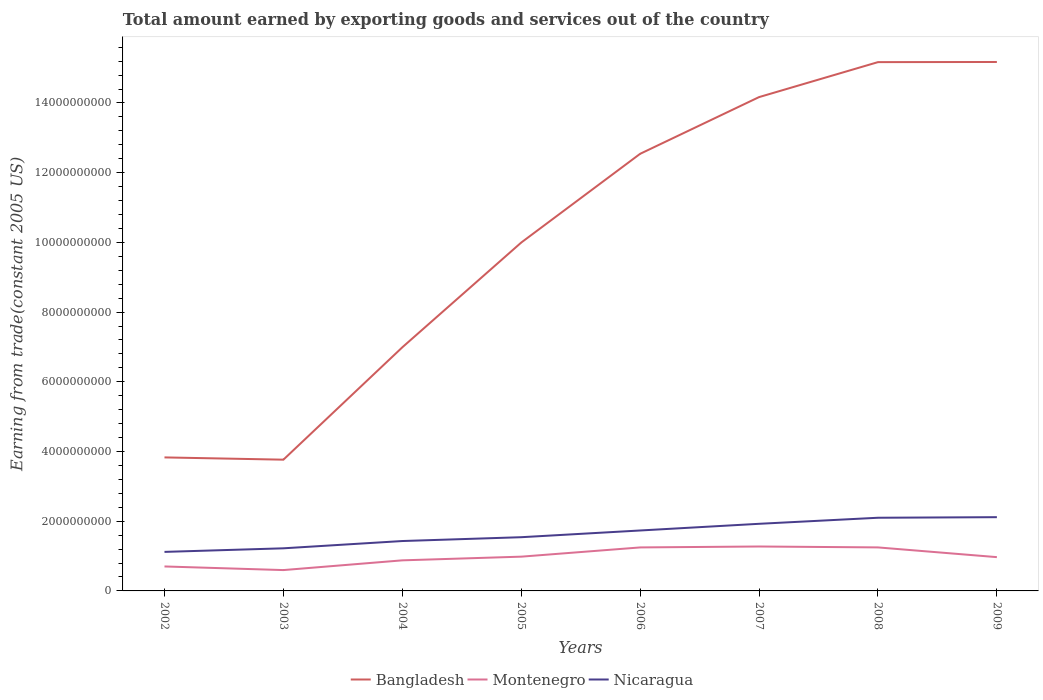How many different coloured lines are there?
Your response must be concise. 3. Does the line corresponding to Nicaragua intersect with the line corresponding to Montenegro?
Ensure brevity in your answer.  No. Is the number of lines equal to the number of legend labels?
Your answer should be very brief. Yes. Across all years, what is the maximum total amount earned by exporting goods and services in Montenegro?
Your response must be concise. 5.98e+08. In which year was the total amount earned by exporting goods and services in Bangladesh maximum?
Your response must be concise. 2003. What is the total total amount earned by exporting goods and services in Montenegro in the graph?
Offer a very short reply. -5.72e+08. What is the difference between the highest and the second highest total amount earned by exporting goods and services in Montenegro?
Provide a short and direct response. 6.76e+08. What is the difference between the highest and the lowest total amount earned by exporting goods and services in Montenegro?
Provide a short and direct response. 3. How many lines are there?
Your response must be concise. 3. How many years are there in the graph?
Your answer should be compact. 8. What is the difference between two consecutive major ticks on the Y-axis?
Your response must be concise. 2.00e+09. Are the values on the major ticks of Y-axis written in scientific E-notation?
Ensure brevity in your answer.  No. Does the graph contain any zero values?
Your response must be concise. No. Does the graph contain grids?
Your answer should be very brief. No. Where does the legend appear in the graph?
Offer a very short reply. Bottom center. How many legend labels are there?
Provide a short and direct response. 3. How are the legend labels stacked?
Provide a short and direct response. Horizontal. What is the title of the graph?
Offer a terse response. Total amount earned by exporting goods and services out of the country. Does "Pacific island small states" appear as one of the legend labels in the graph?
Give a very brief answer. No. What is the label or title of the Y-axis?
Provide a short and direct response. Earning from trade(constant 2005 US). What is the Earning from trade(constant 2005 US) of Bangladesh in 2002?
Keep it short and to the point. 3.83e+09. What is the Earning from trade(constant 2005 US) of Montenegro in 2002?
Give a very brief answer. 7.02e+08. What is the Earning from trade(constant 2005 US) in Nicaragua in 2002?
Your response must be concise. 1.12e+09. What is the Earning from trade(constant 2005 US) of Bangladesh in 2003?
Provide a succinct answer. 3.77e+09. What is the Earning from trade(constant 2005 US) in Montenegro in 2003?
Provide a short and direct response. 5.98e+08. What is the Earning from trade(constant 2005 US) of Nicaragua in 2003?
Provide a short and direct response. 1.22e+09. What is the Earning from trade(constant 2005 US) in Bangladesh in 2004?
Provide a succinct answer. 6.99e+09. What is the Earning from trade(constant 2005 US) of Montenegro in 2004?
Keep it short and to the point. 8.77e+08. What is the Earning from trade(constant 2005 US) in Nicaragua in 2004?
Your answer should be very brief. 1.43e+09. What is the Earning from trade(constant 2005 US) in Bangladesh in 2005?
Your answer should be very brief. 9.99e+09. What is the Earning from trade(constant 2005 US) in Montenegro in 2005?
Provide a succinct answer. 9.83e+08. What is the Earning from trade(constant 2005 US) of Nicaragua in 2005?
Your answer should be very brief. 1.54e+09. What is the Earning from trade(constant 2005 US) in Bangladesh in 2006?
Offer a terse response. 1.25e+1. What is the Earning from trade(constant 2005 US) of Montenegro in 2006?
Ensure brevity in your answer.  1.25e+09. What is the Earning from trade(constant 2005 US) in Nicaragua in 2006?
Offer a very short reply. 1.73e+09. What is the Earning from trade(constant 2005 US) of Bangladesh in 2007?
Offer a very short reply. 1.42e+1. What is the Earning from trade(constant 2005 US) of Montenegro in 2007?
Offer a terse response. 1.27e+09. What is the Earning from trade(constant 2005 US) in Nicaragua in 2007?
Keep it short and to the point. 1.93e+09. What is the Earning from trade(constant 2005 US) of Bangladesh in 2008?
Provide a short and direct response. 1.52e+1. What is the Earning from trade(constant 2005 US) of Montenegro in 2008?
Provide a short and direct response. 1.25e+09. What is the Earning from trade(constant 2005 US) in Nicaragua in 2008?
Your answer should be very brief. 2.10e+09. What is the Earning from trade(constant 2005 US) of Bangladesh in 2009?
Your answer should be compact. 1.52e+1. What is the Earning from trade(constant 2005 US) in Montenegro in 2009?
Ensure brevity in your answer.  9.69e+08. What is the Earning from trade(constant 2005 US) of Nicaragua in 2009?
Offer a very short reply. 2.12e+09. Across all years, what is the maximum Earning from trade(constant 2005 US) of Bangladesh?
Provide a short and direct response. 1.52e+1. Across all years, what is the maximum Earning from trade(constant 2005 US) of Montenegro?
Provide a succinct answer. 1.27e+09. Across all years, what is the maximum Earning from trade(constant 2005 US) in Nicaragua?
Make the answer very short. 2.12e+09. Across all years, what is the minimum Earning from trade(constant 2005 US) in Bangladesh?
Your answer should be compact. 3.77e+09. Across all years, what is the minimum Earning from trade(constant 2005 US) in Montenegro?
Provide a succinct answer. 5.98e+08. Across all years, what is the minimum Earning from trade(constant 2005 US) in Nicaragua?
Your answer should be compact. 1.12e+09. What is the total Earning from trade(constant 2005 US) in Bangladesh in the graph?
Give a very brief answer. 8.16e+1. What is the total Earning from trade(constant 2005 US) in Montenegro in the graph?
Offer a very short reply. 7.90e+09. What is the total Earning from trade(constant 2005 US) of Nicaragua in the graph?
Offer a terse response. 1.32e+1. What is the difference between the Earning from trade(constant 2005 US) of Bangladesh in 2002 and that in 2003?
Give a very brief answer. 6.50e+07. What is the difference between the Earning from trade(constant 2005 US) in Montenegro in 2002 and that in 2003?
Make the answer very short. 1.04e+08. What is the difference between the Earning from trade(constant 2005 US) in Nicaragua in 2002 and that in 2003?
Your response must be concise. -1.03e+08. What is the difference between the Earning from trade(constant 2005 US) of Bangladesh in 2002 and that in 2004?
Your response must be concise. -3.16e+09. What is the difference between the Earning from trade(constant 2005 US) of Montenegro in 2002 and that in 2004?
Your answer should be very brief. -1.75e+08. What is the difference between the Earning from trade(constant 2005 US) of Nicaragua in 2002 and that in 2004?
Your answer should be compact. -3.12e+08. What is the difference between the Earning from trade(constant 2005 US) of Bangladesh in 2002 and that in 2005?
Provide a succinct answer. -6.16e+09. What is the difference between the Earning from trade(constant 2005 US) in Montenegro in 2002 and that in 2005?
Give a very brief answer. -2.81e+08. What is the difference between the Earning from trade(constant 2005 US) in Nicaragua in 2002 and that in 2005?
Make the answer very short. -4.22e+08. What is the difference between the Earning from trade(constant 2005 US) of Bangladesh in 2002 and that in 2006?
Provide a short and direct response. -8.71e+09. What is the difference between the Earning from trade(constant 2005 US) in Montenegro in 2002 and that in 2006?
Keep it short and to the point. -5.46e+08. What is the difference between the Earning from trade(constant 2005 US) of Nicaragua in 2002 and that in 2006?
Make the answer very short. -6.14e+08. What is the difference between the Earning from trade(constant 2005 US) of Bangladesh in 2002 and that in 2007?
Your answer should be very brief. -1.03e+1. What is the difference between the Earning from trade(constant 2005 US) of Montenegro in 2002 and that in 2007?
Make the answer very short. -5.72e+08. What is the difference between the Earning from trade(constant 2005 US) of Nicaragua in 2002 and that in 2007?
Provide a succinct answer. -8.06e+08. What is the difference between the Earning from trade(constant 2005 US) in Bangladesh in 2002 and that in 2008?
Your answer should be very brief. -1.13e+1. What is the difference between the Earning from trade(constant 2005 US) in Montenegro in 2002 and that in 2008?
Make the answer very short. -5.46e+08. What is the difference between the Earning from trade(constant 2005 US) in Nicaragua in 2002 and that in 2008?
Provide a succinct answer. -9.80e+08. What is the difference between the Earning from trade(constant 2005 US) in Bangladesh in 2002 and that in 2009?
Provide a short and direct response. -1.13e+1. What is the difference between the Earning from trade(constant 2005 US) of Montenegro in 2002 and that in 2009?
Give a very brief answer. -2.67e+08. What is the difference between the Earning from trade(constant 2005 US) in Nicaragua in 2002 and that in 2009?
Offer a terse response. -9.96e+08. What is the difference between the Earning from trade(constant 2005 US) of Bangladesh in 2003 and that in 2004?
Ensure brevity in your answer.  -3.22e+09. What is the difference between the Earning from trade(constant 2005 US) of Montenegro in 2003 and that in 2004?
Keep it short and to the point. -2.79e+08. What is the difference between the Earning from trade(constant 2005 US) of Nicaragua in 2003 and that in 2004?
Your response must be concise. -2.09e+08. What is the difference between the Earning from trade(constant 2005 US) in Bangladesh in 2003 and that in 2005?
Your response must be concise. -6.23e+09. What is the difference between the Earning from trade(constant 2005 US) of Montenegro in 2003 and that in 2005?
Give a very brief answer. -3.85e+08. What is the difference between the Earning from trade(constant 2005 US) of Nicaragua in 2003 and that in 2005?
Provide a short and direct response. -3.19e+08. What is the difference between the Earning from trade(constant 2005 US) in Bangladesh in 2003 and that in 2006?
Keep it short and to the point. -8.78e+09. What is the difference between the Earning from trade(constant 2005 US) of Montenegro in 2003 and that in 2006?
Your response must be concise. -6.50e+08. What is the difference between the Earning from trade(constant 2005 US) in Nicaragua in 2003 and that in 2006?
Ensure brevity in your answer.  -5.11e+08. What is the difference between the Earning from trade(constant 2005 US) of Bangladesh in 2003 and that in 2007?
Offer a terse response. -1.04e+1. What is the difference between the Earning from trade(constant 2005 US) in Montenegro in 2003 and that in 2007?
Provide a succinct answer. -6.76e+08. What is the difference between the Earning from trade(constant 2005 US) of Nicaragua in 2003 and that in 2007?
Your answer should be very brief. -7.03e+08. What is the difference between the Earning from trade(constant 2005 US) in Bangladesh in 2003 and that in 2008?
Your answer should be compact. -1.14e+1. What is the difference between the Earning from trade(constant 2005 US) of Montenegro in 2003 and that in 2008?
Your response must be concise. -6.50e+08. What is the difference between the Earning from trade(constant 2005 US) in Nicaragua in 2003 and that in 2008?
Provide a succinct answer. -8.77e+08. What is the difference between the Earning from trade(constant 2005 US) in Bangladesh in 2003 and that in 2009?
Offer a very short reply. -1.14e+1. What is the difference between the Earning from trade(constant 2005 US) of Montenegro in 2003 and that in 2009?
Provide a succinct answer. -3.71e+08. What is the difference between the Earning from trade(constant 2005 US) of Nicaragua in 2003 and that in 2009?
Keep it short and to the point. -8.94e+08. What is the difference between the Earning from trade(constant 2005 US) of Bangladesh in 2004 and that in 2005?
Give a very brief answer. -3.01e+09. What is the difference between the Earning from trade(constant 2005 US) of Montenegro in 2004 and that in 2005?
Provide a short and direct response. -1.06e+08. What is the difference between the Earning from trade(constant 2005 US) in Nicaragua in 2004 and that in 2005?
Keep it short and to the point. -1.10e+08. What is the difference between the Earning from trade(constant 2005 US) of Bangladesh in 2004 and that in 2006?
Your response must be concise. -5.55e+09. What is the difference between the Earning from trade(constant 2005 US) in Montenegro in 2004 and that in 2006?
Your response must be concise. -3.70e+08. What is the difference between the Earning from trade(constant 2005 US) in Nicaragua in 2004 and that in 2006?
Your response must be concise. -3.02e+08. What is the difference between the Earning from trade(constant 2005 US) in Bangladesh in 2004 and that in 2007?
Offer a very short reply. -7.18e+09. What is the difference between the Earning from trade(constant 2005 US) of Montenegro in 2004 and that in 2007?
Your answer should be compact. -3.97e+08. What is the difference between the Earning from trade(constant 2005 US) in Nicaragua in 2004 and that in 2007?
Your answer should be compact. -4.94e+08. What is the difference between the Earning from trade(constant 2005 US) in Bangladesh in 2004 and that in 2008?
Offer a terse response. -8.18e+09. What is the difference between the Earning from trade(constant 2005 US) in Montenegro in 2004 and that in 2008?
Ensure brevity in your answer.  -3.71e+08. What is the difference between the Earning from trade(constant 2005 US) of Nicaragua in 2004 and that in 2008?
Provide a succinct answer. -6.68e+08. What is the difference between the Earning from trade(constant 2005 US) of Bangladesh in 2004 and that in 2009?
Your answer should be very brief. -8.19e+09. What is the difference between the Earning from trade(constant 2005 US) in Montenegro in 2004 and that in 2009?
Your response must be concise. -9.19e+07. What is the difference between the Earning from trade(constant 2005 US) of Nicaragua in 2004 and that in 2009?
Your answer should be compact. -6.85e+08. What is the difference between the Earning from trade(constant 2005 US) of Bangladesh in 2005 and that in 2006?
Make the answer very short. -2.55e+09. What is the difference between the Earning from trade(constant 2005 US) of Montenegro in 2005 and that in 2006?
Offer a terse response. -2.65e+08. What is the difference between the Earning from trade(constant 2005 US) in Nicaragua in 2005 and that in 2006?
Give a very brief answer. -1.93e+08. What is the difference between the Earning from trade(constant 2005 US) in Bangladesh in 2005 and that in 2007?
Offer a terse response. -4.17e+09. What is the difference between the Earning from trade(constant 2005 US) in Montenegro in 2005 and that in 2007?
Provide a short and direct response. -2.91e+08. What is the difference between the Earning from trade(constant 2005 US) in Nicaragua in 2005 and that in 2007?
Provide a short and direct response. -3.84e+08. What is the difference between the Earning from trade(constant 2005 US) of Bangladesh in 2005 and that in 2008?
Make the answer very short. -5.18e+09. What is the difference between the Earning from trade(constant 2005 US) in Montenegro in 2005 and that in 2008?
Offer a terse response. -2.65e+08. What is the difference between the Earning from trade(constant 2005 US) in Nicaragua in 2005 and that in 2008?
Your response must be concise. -5.58e+08. What is the difference between the Earning from trade(constant 2005 US) of Bangladesh in 2005 and that in 2009?
Offer a terse response. -5.18e+09. What is the difference between the Earning from trade(constant 2005 US) of Montenegro in 2005 and that in 2009?
Offer a terse response. 1.37e+07. What is the difference between the Earning from trade(constant 2005 US) in Nicaragua in 2005 and that in 2009?
Offer a terse response. -5.75e+08. What is the difference between the Earning from trade(constant 2005 US) of Bangladesh in 2006 and that in 2007?
Give a very brief answer. -1.63e+09. What is the difference between the Earning from trade(constant 2005 US) of Montenegro in 2006 and that in 2007?
Your response must be concise. -2.65e+07. What is the difference between the Earning from trade(constant 2005 US) in Nicaragua in 2006 and that in 2007?
Your answer should be compact. -1.92e+08. What is the difference between the Earning from trade(constant 2005 US) of Bangladesh in 2006 and that in 2008?
Ensure brevity in your answer.  -2.63e+09. What is the difference between the Earning from trade(constant 2005 US) in Montenegro in 2006 and that in 2008?
Keep it short and to the point. -4.10e+05. What is the difference between the Earning from trade(constant 2005 US) in Nicaragua in 2006 and that in 2008?
Provide a succinct answer. -3.66e+08. What is the difference between the Earning from trade(constant 2005 US) in Bangladesh in 2006 and that in 2009?
Provide a succinct answer. -2.63e+09. What is the difference between the Earning from trade(constant 2005 US) of Montenegro in 2006 and that in 2009?
Your response must be concise. 2.79e+08. What is the difference between the Earning from trade(constant 2005 US) in Nicaragua in 2006 and that in 2009?
Offer a terse response. -3.82e+08. What is the difference between the Earning from trade(constant 2005 US) of Bangladesh in 2007 and that in 2008?
Offer a very short reply. -1.00e+09. What is the difference between the Earning from trade(constant 2005 US) in Montenegro in 2007 and that in 2008?
Offer a very short reply. 2.61e+07. What is the difference between the Earning from trade(constant 2005 US) in Nicaragua in 2007 and that in 2008?
Your response must be concise. -1.74e+08. What is the difference between the Earning from trade(constant 2005 US) of Bangladesh in 2007 and that in 2009?
Your response must be concise. -1.01e+09. What is the difference between the Earning from trade(constant 2005 US) of Montenegro in 2007 and that in 2009?
Provide a short and direct response. 3.05e+08. What is the difference between the Earning from trade(constant 2005 US) of Nicaragua in 2007 and that in 2009?
Provide a short and direct response. -1.90e+08. What is the difference between the Earning from trade(constant 2005 US) in Bangladesh in 2008 and that in 2009?
Keep it short and to the point. -4.32e+06. What is the difference between the Earning from trade(constant 2005 US) of Montenegro in 2008 and that in 2009?
Your answer should be very brief. 2.79e+08. What is the difference between the Earning from trade(constant 2005 US) of Nicaragua in 2008 and that in 2009?
Your answer should be compact. -1.68e+07. What is the difference between the Earning from trade(constant 2005 US) of Bangladesh in 2002 and the Earning from trade(constant 2005 US) of Montenegro in 2003?
Make the answer very short. 3.23e+09. What is the difference between the Earning from trade(constant 2005 US) of Bangladesh in 2002 and the Earning from trade(constant 2005 US) of Nicaragua in 2003?
Offer a very short reply. 2.61e+09. What is the difference between the Earning from trade(constant 2005 US) in Montenegro in 2002 and the Earning from trade(constant 2005 US) in Nicaragua in 2003?
Offer a very short reply. -5.20e+08. What is the difference between the Earning from trade(constant 2005 US) of Bangladesh in 2002 and the Earning from trade(constant 2005 US) of Montenegro in 2004?
Offer a terse response. 2.95e+09. What is the difference between the Earning from trade(constant 2005 US) of Bangladesh in 2002 and the Earning from trade(constant 2005 US) of Nicaragua in 2004?
Ensure brevity in your answer.  2.40e+09. What is the difference between the Earning from trade(constant 2005 US) in Montenegro in 2002 and the Earning from trade(constant 2005 US) in Nicaragua in 2004?
Offer a terse response. -7.29e+08. What is the difference between the Earning from trade(constant 2005 US) of Bangladesh in 2002 and the Earning from trade(constant 2005 US) of Montenegro in 2005?
Provide a short and direct response. 2.85e+09. What is the difference between the Earning from trade(constant 2005 US) in Bangladesh in 2002 and the Earning from trade(constant 2005 US) in Nicaragua in 2005?
Ensure brevity in your answer.  2.29e+09. What is the difference between the Earning from trade(constant 2005 US) of Montenegro in 2002 and the Earning from trade(constant 2005 US) of Nicaragua in 2005?
Keep it short and to the point. -8.39e+08. What is the difference between the Earning from trade(constant 2005 US) of Bangladesh in 2002 and the Earning from trade(constant 2005 US) of Montenegro in 2006?
Offer a terse response. 2.58e+09. What is the difference between the Earning from trade(constant 2005 US) of Bangladesh in 2002 and the Earning from trade(constant 2005 US) of Nicaragua in 2006?
Offer a very short reply. 2.10e+09. What is the difference between the Earning from trade(constant 2005 US) of Montenegro in 2002 and the Earning from trade(constant 2005 US) of Nicaragua in 2006?
Give a very brief answer. -1.03e+09. What is the difference between the Earning from trade(constant 2005 US) of Bangladesh in 2002 and the Earning from trade(constant 2005 US) of Montenegro in 2007?
Provide a short and direct response. 2.56e+09. What is the difference between the Earning from trade(constant 2005 US) in Bangladesh in 2002 and the Earning from trade(constant 2005 US) in Nicaragua in 2007?
Your answer should be compact. 1.90e+09. What is the difference between the Earning from trade(constant 2005 US) in Montenegro in 2002 and the Earning from trade(constant 2005 US) in Nicaragua in 2007?
Your response must be concise. -1.22e+09. What is the difference between the Earning from trade(constant 2005 US) in Bangladesh in 2002 and the Earning from trade(constant 2005 US) in Montenegro in 2008?
Provide a succinct answer. 2.58e+09. What is the difference between the Earning from trade(constant 2005 US) in Bangladesh in 2002 and the Earning from trade(constant 2005 US) in Nicaragua in 2008?
Your answer should be very brief. 1.73e+09. What is the difference between the Earning from trade(constant 2005 US) in Montenegro in 2002 and the Earning from trade(constant 2005 US) in Nicaragua in 2008?
Your response must be concise. -1.40e+09. What is the difference between the Earning from trade(constant 2005 US) of Bangladesh in 2002 and the Earning from trade(constant 2005 US) of Montenegro in 2009?
Offer a terse response. 2.86e+09. What is the difference between the Earning from trade(constant 2005 US) in Bangladesh in 2002 and the Earning from trade(constant 2005 US) in Nicaragua in 2009?
Offer a terse response. 1.71e+09. What is the difference between the Earning from trade(constant 2005 US) of Montenegro in 2002 and the Earning from trade(constant 2005 US) of Nicaragua in 2009?
Keep it short and to the point. -1.41e+09. What is the difference between the Earning from trade(constant 2005 US) in Bangladesh in 2003 and the Earning from trade(constant 2005 US) in Montenegro in 2004?
Your answer should be very brief. 2.89e+09. What is the difference between the Earning from trade(constant 2005 US) in Bangladesh in 2003 and the Earning from trade(constant 2005 US) in Nicaragua in 2004?
Keep it short and to the point. 2.33e+09. What is the difference between the Earning from trade(constant 2005 US) of Montenegro in 2003 and the Earning from trade(constant 2005 US) of Nicaragua in 2004?
Your answer should be very brief. -8.34e+08. What is the difference between the Earning from trade(constant 2005 US) of Bangladesh in 2003 and the Earning from trade(constant 2005 US) of Montenegro in 2005?
Give a very brief answer. 2.78e+09. What is the difference between the Earning from trade(constant 2005 US) of Bangladesh in 2003 and the Earning from trade(constant 2005 US) of Nicaragua in 2005?
Your answer should be very brief. 2.22e+09. What is the difference between the Earning from trade(constant 2005 US) in Montenegro in 2003 and the Earning from trade(constant 2005 US) in Nicaragua in 2005?
Keep it short and to the point. -9.43e+08. What is the difference between the Earning from trade(constant 2005 US) in Bangladesh in 2003 and the Earning from trade(constant 2005 US) in Montenegro in 2006?
Offer a very short reply. 2.52e+09. What is the difference between the Earning from trade(constant 2005 US) of Bangladesh in 2003 and the Earning from trade(constant 2005 US) of Nicaragua in 2006?
Keep it short and to the point. 2.03e+09. What is the difference between the Earning from trade(constant 2005 US) of Montenegro in 2003 and the Earning from trade(constant 2005 US) of Nicaragua in 2006?
Make the answer very short. -1.14e+09. What is the difference between the Earning from trade(constant 2005 US) of Bangladesh in 2003 and the Earning from trade(constant 2005 US) of Montenegro in 2007?
Make the answer very short. 2.49e+09. What is the difference between the Earning from trade(constant 2005 US) of Bangladesh in 2003 and the Earning from trade(constant 2005 US) of Nicaragua in 2007?
Give a very brief answer. 1.84e+09. What is the difference between the Earning from trade(constant 2005 US) of Montenegro in 2003 and the Earning from trade(constant 2005 US) of Nicaragua in 2007?
Offer a very short reply. -1.33e+09. What is the difference between the Earning from trade(constant 2005 US) in Bangladesh in 2003 and the Earning from trade(constant 2005 US) in Montenegro in 2008?
Your answer should be very brief. 2.52e+09. What is the difference between the Earning from trade(constant 2005 US) in Bangladesh in 2003 and the Earning from trade(constant 2005 US) in Nicaragua in 2008?
Keep it short and to the point. 1.67e+09. What is the difference between the Earning from trade(constant 2005 US) of Montenegro in 2003 and the Earning from trade(constant 2005 US) of Nicaragua in 2008?
Provide a short and direct response. -1.50e+09. What is the difference between the Earning from trade(constant 2005 US) in Bangladesh in 2003 and the Earning from trade(constant 2005 US) in Montenegro in 2009?
Keep it short and to the point. 2.80e+09. What is the difference between the Earning from trade(constant 2005 US) of Bangladesh in 2003 and the Earning from trade(constant 2005 US) of Nicaragua in 2009?
Ensure brevity in your answer.  1.65e+09. What is the difference between the Earning from trade(constant 2005 US) of Montenegro in 2003 and the Earning from trade(constant 2005 US) of Nicaragua in 2009?
Give a very brief answer. -1.52e+09. What is the difference between the Earning from trade(constant 2005 US) in Bangladesh in 2004 and the Earning from trade(constant 2005 US) in Montenegro in 2005?
Your answer should be compact. 6.01e+09. What is the difference between the Earning from trade(constant 2005 US) in Bangladesh in 2004 and the Earning from trade(constant 2005 US) in Nicaragua in 2005?
Ensure brevity in your answer.  5.45e+09. What is the difference between the Earning from trade(constant 2005 US) of Montenegro in 2004 and the Earning from trade(constant 2005 US) of Nicaragua in 2005?
Ensure brevity in your answer.  -6.64e+08. What is the difference between the Earning from trade(constant 2005 US) of Bangladesh in 2004 and the Earning from trade(constant 2005 US) of Montenegro in 2006?
Provide a succinct answer. 5.74e+09. What is the difference between the Earning from trade(constant 2005 US) in Bangladesh in 2004 and the Earning from trade(constant 2005 US) in Nicaragua in 2006?
Ensure brevity in your answer.  5.26e+09. What is the difference between the Earning from trade(constant 2005 US) in Montenegro in 2004 and the Earning from trade(constant 2005 US) in Nicaragua in 2006?
Your answer should be very brief. -8.56e+08. What is the difference between the Earning from trade(constant 2005 US) of Bangladesh in 2004 and the Earning from trade(constant 2005 US) of Montenegro in 2007?
Your response must be concise. 5.71e+09. What is the difference between the Earning from trade(constant 2005 US) of Bangladesh in 2004 and the Earning from trade(constant 2005 US) of Nicaragua in 2007?
Make the answer very short. 5.06e+09. What is the difference between the Earning from trade(constant 2005 US) of Montenegro in 2004 and the Earning from trade(constant 2005 US) of Nicaragua in 2007?
Offer a very short reply. -1.05e+09. What is the difference between the Earning from trade(constant 2005 US) of Bangladesh in 2004 and the Earning from trade(constant 2005 US) of Montenegro in 2008?
Give a very brief answer. 5.74e+09. What is the difference between the Earning from trade(constant 2005 US) in Bangladesh in 2004 and the Earning from trade(constant 2005 US) in Nicaragua in 2008?
Your answer should be very brief. 4.89e+09. What is the difference between the Earning from trade(constant 2005 US) in Montenegro in 2004 and the Earning from trade(constant 2005 US) in Nicaragua in 2008?
Your answer should be compact. -1.22e+09. What is the difference between the Earning from trade(constant 2005 US) in Bangladesh in 2004 and the Earning from trade(constant 2005 US) in Montenegro in 2009?
Provide a succinct answer. 6.02e+09. What is the difference between the Earning from trade(constant 2005 US) in Bangladesh in 2004 and the Earning from trade(constant 2005 US) in Nicaragua in 2009?
Your answer should be very brief. 4.87e+09. What is the difference between the Earning from trade(constant 2005 US) of Montenegro in 2004 and the Earning from trade(constant 2005 US) of Nicaragua in 2009?
Provide a succinct answer. -1.24e+09. What is the difference between the Earning from trade(constant 2005 US) of Bangladesh in 2005 and the Earning from trade(constant 2005 US) of Montenegro in 2006?
Provide a short and direct response. 8.75e+09. What is the difference between the Earning from trade(constant 2005 US) in Bangladesh in 2005 and the Earning from trade(constant 2005 US) in Nicaragua in 2006?
Provide a short and direct response. 8.26e+09. What is the difference between the Earning from trade(constant 2005 US) of Montenegro in 2005 and the Earning from trade(constant 2005 US) of Nicaragua in 2006?
Make the answer very short. -7.51e+08. What is the difference between the Earning from trade(constant 2005 US) of Bangladesh in 2005 and the Earning from trade(constant 2005 US) of Montenegro in 2007?
Your answer should be very brief. 8.72e+09. What is the difference between the Earning from trade(constant 2005 US) in Bangladesh in 2005 and the Earning from trade(constant 2005 US) in Nicaragua in 2007?
Your answer should be compact. 8.07e+09. What is the difference between the Earning from trade(constant 2005 US) in Montenegro in 2005 and the Earning from trade(constant 2005 US) in Nicaragua in 2007?
Ensure brevity in your answer.  -9.43e+08. What is the difference between the Earning from trade(constant 2005 US) in Bangladesh in 2005 and the Earning from trade(constant 2005 US) in Montenegro in 2008?
Offer a terse response. 8.75e+09. What is the difference between the Earning from trade(constant 2005 US) in Bangladesh in 2005 and the Earning from trade(constant 2005 US) in Nicaragua in 2008?
Keep it short and to the point. 7.90e+09. What is the difference between the Earning from trade(constant 2005 US) of Montenegro in 2005 and the Earning from trade(constant 2005 US) of Nicaragua in 2008?
Your response must be concise. -1.12e+09. What is the difference between the Earning from trade(constant 2005 US) in Bangladesh in 2005 and the Earning from trade(constant 2005 US) in Montenegro in 2009?
Your response must be concise. 9.03e+09. What is the difference between the Earning from trade(constant 2005 US) of Bangladesh in 2005 and the Earning from trade(constant 2005 US) of Nicaragua in 2009?
Offer a very short reply. 7.88e+09. What is the difference between the Earning from trade(constant 2005 US) of Montenegro in 2005 and the Earning from trade(constant 2005 US) of Nicaragua in 2009?
Ensure brevity in your answer.  -1.13e+09. What is the difference between the Earning from trade(constant 2005 US) in Bangladesh in 2006 and the Earning from trade(constant 2005 US) in Montenegro in 2007?
Offer a very short reply. 1.13e+1. What is the difference between the Earning from trade(constant 2005 US) in Bangladesh in 2006 and the Earning from trade(constant 2005 US) in Nicaragua in 2007?
Offer a terse response. 1.06e+1. What is the difference between the Earning from trade(constant 2005 US) of Montenegro in 2006 and the Earning from trade(constant 2005 US) of Nicaragua in 2007?
Your answer should be very brief. -6.78e+08. What is the difference between the Earning from trade(constant 2005 US) of Bangladesh in 2006 and the Earning from trade(constant 2005 US) of Montenegro in 2008?
Provide a succinct answer. 1.13e+1. What is the difference between the Earning from trade(constant 2005 US) in Bangladesh in 2006 and the Earning from trade(constant 2005 US) in Nicaragua in 2008?
Keep it short and to the point. 1.04e+1. What is the difference between the Earning from trade(constant 2005 US) in Montenegro in 2006 and the Earning from trade(constant 2005 US) in Nicaragua in 2008?
Provide a succinct answer. -8.51e+08. What is the difference between the Earning from trade(constant 2005 US) of Bangladesh in 2006 and the Earning from trade(constant 2005 US) of Montenegro in 2009?
Offer a terse response. 1.16e+1. What is the difference between the Earning from trade(constant 2005 US) of Bangladesh in 2006 and the Earning from trade(constant 2005 US) of Nicaragua in 2009?
Keep it short and to the point. 1.04e+1. What is the difference between the Earning from trade(constant 2005 US) in Montenegro in 2006 and the Earning from trade(constant 2005 US) in Nicaragua in 2009?
Give a very brief answer. -8.68e+08. What is the difference between the Earning from trade(constant 2005 US) in Bangladesh in 2007 and the Earning from trade(constant 2005 US) in Montenegro in 2008?
Offer a very short reply. 1.29e+1. What is the difference between the Earning from trade(constant 2005 US) in Bangladesh in 2007 and the Earning from trade(constant 2005 US) in Nicaragua in 2008?
Provide a succinct answer. 1.21e+1. What is the difference between the Earning from trade(constant 2005 US) of Montenegro in 2007 and the Earning from trade(constant 2005 US) of Nicaragua in 2008?
Your answer should be compact. -8.25e+08. What is the difference between the Earning from trade(constant 2005 US) in Bangladesh in 2007 and the Earning from trade(constant 2005 US) in Montenegro in 2009?
Your answer should be compact. 1.32e+1. What is the difference between the Earning from trade(constant 2005 US) in Bangladesh in 2007 and the Earning from trade(constant 2005 US) in Nicaragua in 2009?
Your answer should be very brief. 1.21e+1. What is the difference between the Earning from trade(constant 2005 US) of Montenegro in 2007 and the Earning from trade(constant 2005 US) of Nicaragua in 2009?
Keep it short and to the point. -8.42e+08. What is the difference between the Earning from trade(constant 2005 US) in Bangladesh in 2008 and the Earning from trade(constant 2005 US) in Montenegro in 2009?
Provide a succinct answer. 1.42e+1. What is the difference between the Earning from trade(constant 2005 US) of Bangladesh in 2008 and the Earning from trade(constant 2005 US) of Nicaragua in 2009?
Offer a very short reply. 1.31e+1. What is the difference between the Earning from trade(constant 2005 US) in Montenegro in 2008 and the Earning from trade(constant 2005 US) in Nicaragua in 2009?
Your response must be concise. -8.68e+08. What is the average Earning from trade(constant 2005 US) of Bangladesh per year?
Your answer should be compact. 1.02e+1. What is the average Earning from trade(constant 2005 US) in Montenegro per year?
Your answer should be very brief. 9.88e+08. What is the average Earning from trade(constant 2005 US) of Nicaragua per year?
Offer a terse response. 1.65e+09. In the year 2002, what is the difference between the Earning from trade(constant 2005 US) of Bangladesh and Earning from trade(constant 2005 US) of Montenegro?
Provide a short and direct response. 3.13e+09. In the year 2002, what is the difference between the Earning from trade(constant 2005 US) in Bangladesh and Earning from trade(constant 2005 US) in Nicaragua?
Keep it short and to the point. 2.71e+09. In the year 2002, what is the difference between the Earning from trade(constant 2005 US) in Montenegro and Earning from trade(constant 2005 US) in Nicaragua?
Provide a succinct answer. -4.18e+08. In the year 2003, what is the difference between the Earning from trade(constant 2005 US) of Bangladesh and Earning from trade(constant 2005 US) of Montenegro?
Keep it short and to the point. 3.17e+09. In the year 2003, what is the difference between the Earning from trade(constant 2005 US) in Bangladesh and Earning from trade(constant 2005 US) in Nicaragua?
Ensure brevity in your answer.  2.54e+09. In the year 2003, what is the difference between the Earning from trade(constant 2005 US) in Montenegro and Earning from trade(constant 2005 US) in Nicaragua?
Your answer should be compact. -6.24e+08. In the year 2004, what is the difference between the Earning from trade(constant 2005 US) of Bangladesh and Earning from trade(constant 2005 US) of Montenegro?
Offer a terse response. 6.11e+09. In the year 2004, what is the difference between the Earning from trade(constant 2005 US) of Bangladesh and Earning from trade(constant 2005 US) of Nicaragua?
Keep it short and to the point. 5.56e+09. In the year 2004, what is the difference between the Earning from trade(constant 2005 US) in Montenegro and Earning from trade(constant 2005 US) in Nicaragua?
Your response must be concise. -5.54e+08. In the year 2005, what is the difference between the Earning from trade(constant 2005 US) of Bangladesh and Earning from trade(constant 2005 US) of Montenegro?
Your answer should be compact. 9.01e+09. In the year 2005, what is the difference between the Earning from trade(constant 2005 US) in Bangladesh and Earning from trade(constant 2005 US) in Nicaragua?
Your response must be concise. 8.45e+09. In the year 2005, what is the difference between the Earning from trade(constant 2005 US) of Montenegro and Earning from trade(constant 2005 US) of Nicaragua?
Provide a succinct answer. -5.58e+08. In the year 2006, what is the difference between the Earning from trade(constant 2005 US) in Bangladesh and Earning from trade(constant 2005 US) in Montenegro?
Offer a very short reply. 1.13e+1. In the year 2006, what is the difference between the Earning from trade(constant 2005 US) in Bangladesh and Earning from trade(constant 2005 US) in Nicaragua?
Ensure brevity in your answer.  1.08e+1. In the year 2006, what is the difference between the Earning from trade(constant 2005 US) of Montenegro and Earning from trade(constant 2005 US) of Nicaragua?
Keep it short and to the point. -4.86e+08. In the year 2007, what is the difference between the Earning from trade(constant 2005 US) of Bangladesh and Earning from trade(constant 2005 US) of Montenegro?
Provide a short and direct response. 1.29e+1. In the year 2007, what is the difference between the Earning from trade(constant 2005 US) in Bangladesh and Earning from trade(constant 2005 US) in Nicaragua?
Ensure brevity in your answer.  1.22e+1. In the year 2007, what is the difference between the Earning from trade(constant 2005 US) in Montenegro and Earning from trade(constant 2005 US) in Nicaragua?
Your answer should be very brief. -6.51e+08. In the year 2008, what is the difference between the Earning from trade(constant 2005 US) in Bangladesh and Earning from trade(constant 2005 US) in Montenegro?
Make the answer very short. 1.39e+1. In the year 2008, what is the difference between the Earning from trade(constant 2005 US) in Bangladesh and Earning from trade(constant 2005 US) in Nicaragua?
Give a very brief answer. 1.31e+1. In the year 2008, what is the difference between the Earning from trade(constant 2005 US) of Montenegro and Earning from trade(constant 2005 US) of Nicaragua?
Keep it short and to the point. -8.51e+08. In the year 2009, what is the difference between the Earning from trade(constant 2005 US) in Bangladesh and Earning from trade(constant 2005 US) in Montenegro?
Your answer should be very brief. 1.42e+1. In the year 2009, what is the difference between the Earning from trade(constant 2005 US) of Bangladesh and Earning from trade(constant 2005 US) of Nicaragua?
Provide a succinct answer. 1.31e+1. In the year 2009, what is the difference between the Earning from trade(constant 2005 US) in Montenegro and Earning from trade(constant 2005 US) in Nicaragua?
Your answer should be very brief. -1.15e+09. What is the ratio of the Earning from trade(constant 2005 US) of Bangladesh in 2002 to that in 2003?
Offer a terse response. 1.02. What is the ratio of the Earning from trade(constant 2005 US) in Montenegro in 2002 to that in 2003?
Your answer should be very brief. 1.17. What is the ratio of the Earning from trade(constant 2005 US) in Nicaragua in 2002 to that in 2003?
Provide a short and direct response. 0.92. What is the ratio of the Earning from trade(constant 2005 US) in Bangladesh in 2002 to that in 2004?
Make the answer very short. 0.55. What is the ratio of the Earning from trade(constant 2005 US) in Montenegro in 2002 to that in 2004?
Provide a short and direct response. 0.8. What is the ratio of the Earning from trade(constant 2005 US) in Nicaragua in 2002 to that in 2004?
Keep it short and to the point. 0.78. What is the ratio of the Earning from trade(constant 2005 US) of Bangladesh in 2002 to that in 2005?
Provide a succinct answer. 0.38. What is the ratio of the Earning from trade(constant 2005 US) in Montenegro in 2002 to that in 2005?
Make the answer very short. 0.71. What is the ratio of the Earning from trade(constant 2005 US) in Nicaragua in 2002 to that in 2005?
Ensure brevity in your answer.  0.73. What is the ratio of the Earning from trade(constant 2005 US) of Bangladesh in 2002 to that in 2006?
Your answer should be very brief. 0.31. What is the ratio of the Earning from trade(constant 2005 US) of Montenegro in 2002 to that in 2006?
Your answer should be compact. 0.56. What is the ratio of the Earning from trade(constant 2005 US) in Nicaragua in 2002 to that in 2006?
Give a very brief answer. 0.65. What is the ratio of the Earning from trade(constant 2005 US) in Bangladesh in 2002 to that in 2007?
Give a very brief answer. 0.27. What is the ratio of the Earning from trade(constant 2005 US) in Montenegro in 2002 to that in 2007?
Your answer should be compact. 0.55. What is the ratio of the Earning from trade(constant 2005 US) of Nicaragua in 2002 to that in 2007?
Keep it short and to the point. 0.58. What is the ratio of the Earning from trade(constant 2005 US) in Bangladesh in 2002 to that in 2008?
Provide a short and direct response. 0.25. What is the ratio of the Earning from trade(constant 2005 US) in Montenegro in 2002 to that in 2008?
Provide a succinct answer. 0.56. What is the ratio of the Earning from trade(constant 2005 US) of Nicaragua in 2002 to that in 2008?
Keep it short and to the point. 0.53. What is the ratio of the Earning from trade(constant 2005 US) of Bangladesh in 2002 to that in 2009?
Ensure brevity in your answer.  0.25. What is the ratio of the Earning from trade(constant 2005 US) of Montenegro in 2002 to that in 2009?
Your response must be concise. 0.72. What is the ratio of the Earning from trade(constant 2005 US) of Nicaragua in 2002 to that in 2009?
Keep it short and to the point. 0.53. What is the ratio of the Earning from trade(constant 2005 US) in Bangladesh in 2003 to that in 2004?
Offer a terse response. 0.54. What is the ratio of the Earning from trade(constant 2005 US) of Montenegro in 2003 to that in 2004?
Your answer should be very brief. 0.68. What is the ratio of the Earning from trade(constant 2005 US) in Nicaragua in 2003 to that in 2004?
Your answer should be very brief. 0.85. What is the ratio of the Earning from trade(constant 2005 US) in Bangladesh in 2003 to that in 2005?
Offer a very short reply. 0.38. What is the ratio of the Earning from trade(constant 2005 US) in Montenegro in 2003 to that in 2005?
Your answer should be compact. 0.61. What is the ratio of the Earning from trade(constant 2005 US) of Nicaragua in 2003 to that in 2005?
Ensure brevity in your answer.  0.79. What is the ratio of the Earning from trade(constant 2005 US) in Bangladesh in 2003 to that in 2006?
Give a very brief answer. 0.3. What is the ratio of the Earning from trade(constant 2005 US) of Montenegro in 2003 to that in 2006?
Make the answer very short. 0.48. What is the ratio of the Earning from trade(constant 2005 US) in Nicaragua in 2003 to that in 2006?
Your answer should be compact. 0.7. What is the ratio of the Earning from trade(constant 2005 US) of Bangladesh in 2003 to that in 2007?
Make the answer very short. 0.27. What is the ratio of the Earning from trade(constant 2005 US) in Montenegro in 2003 to that in 2007?
Provide a short and direct response. 0.47. What is the ratio of the Earning from trade(constant 2005 US) of Nicaragua in 2003 to that in 2007?
Your answer should be very brief. 0.63. What is the ratio of the Earning from trade(constant 2005 US) of Bangladesh in 2003 to that in 2008?
Your answer should be compact. 0.25. What is the ratio of the Earning from trade(constant 2005 US) in Montenegro in 2003 to that in 2008?
Provide a succinct answer. 0.48. What is the ratio of the Earning from trade(constant 2005 US) of Nicaragua in 2003 to that in 2008?
Keep it short and to the point. 0.58. What is the ratio of the Earning from trade(constant 2005 US) in Bangladesh in 2003 to that in 2009?
Provide a short and direct response. 0.25. What is the ratio of the Earning from trade(constant 2005 US) of Montenegro in 2003 to that in 2009?
Provide a short and direct response. 0.62. What is the ratio of the Earning from trade(constant 2005 US) in Nicaragua in 2003 to that in 2009?
Provide a short and direct response. 0.58. What is the ratio of the Earning from trade(constant 2005 US) in Bangladesh in 2004 to that in 2005?
Give a very brief answer. 0.7. What is the ratio of the Earning from trade(constant 2005 US) of Montenegro in 2004 to that in 2005?
Your response must be concise. 0.89. What is the ratio of the Earning from trade(constant 2005 US) of Nicaragua in 2004 to that in 2005?
Keep it short and to the point. 0.93. What is the ratio of the Earning from trade(constant 2005 US) of Bangladesh in 2004 to that in 2006?
Offer a terse response. 0.56. What is the ratio of the Earning from trade(constant 2005 US) in Montenegro in 2004 to that in 2006?
Make the answer very short. 0.7. What is the ratio of the Earning from trade(constant 2005 US) in Nicaragua in 2004 to that in 2006?
Your response must be concise. 0.83. What is the ratio of the Earning from trade(constant 2005 US) of Bangladesh in 2004 to that in 2007?
Ensure brevity in your answer.  0.49. What is the ratio of the Earning from trade(constant 2005 US) of Montenegro in 2004 to that in 2007?
Keep it short and to the point. 0.69. What is the ratio of the Earning from trade(constant 2005 US) of Nicaragua in 2004 to that in 2007?
Ensure brevity in your answer.  0.74. What is the ratio of the Earning from trade(constant 2005 US) in Bangladesh in 2004 to that in 2008?
Offer a very short reply. 0.46. What is the ratio of the Earning from trade(constant 2005 US) in Montenegro in 2004 to that in 2008?
Provide a short and direct response. 0.7. What is the ratio of the Earning from trade(constant 2005 US) in Nicaragua in 2004 to that in 2008?
Offer a terse response. 0.68. What is the ratio of the Earning from trade(constant 2005 US) in Bangladesh in 2004 to that in 2009?
Give a very brief answer. 0.46. What is the ratio of the Earning from trade(constant 2005 US) in Montenegro in 2004 to that in 2009?
Your answer should be compact. 0.91. What is the ratio of the Earning from trade(constant 2005 US) in Nicaragua in 2004 to that in 2009?
Give a very brief answer. 0.68. What is the ratio of the Earning from trade(constant 2005 US) in Bangladesh in 2005 to that in 2006?
Give a very brief answer. 0.8. What is the ratio of the Earning from trade(constant 2005 US) of Montenegro in 2005 to that in 2006?
Offer a very short reply. 0.79. What is the ratio of the Earning from trade(constant 2005 US) in Nicaragua in 2005 to that in 2006?
Make the answer very short. 0.89. What is the ratio of the Earning from trade(constant 2005 US) of Bangladesh in 2005 to that in 2007?
Your answer should be compact. 0.71. What is the ratio of the Earning from trade(constant 2005 US) in Montenegro in 2005 to that in 2007?
Your answer should be compact. 0.77. What is the ratio of the Earning from trade(constant 2005 US) of Nicaragua in 2005 to that in 2007?
Offer a terse response. 0.8. What is the ratio of the Earning from trade(constant 2005 US) in Bangladesh in 2005 to that in 2008?
Offer a terse response. 0.66. What is the ratio of the Earning from trade(constant 2005 US) in Montenegro in 2005 to that in 2008?
Your response must be concise. 0.79. What is the ratio of the Earning from trade(constant 2005 US) of Nicaragua in 2005 to that in 2008?
Your response must be concise. 0.73. What is the ratio of the Earning from trade(constant 2005 US) of Bangladesh in 2005 to that in 2009?
Your response must be concise. 0.66. What is the ratio of the Earning from trade(constant 2005 US) of Montenegro in 2005 to that in 2009?
Offer a terse response. 1.01. What is the ratio of the Earning from trade(constant 2005 US) in Nicaragua in 2005 to that in 2009?
Your response must be concise. 0.73. What is the ratio of the Earning from trade(constant 2005 US) in Bangladesh in 2006 to that in 2007?
Keep it short and to the point. 0.89. What is the ratio of the Earning from trade(constant 2005 US) of Montenegro in 2006 to that in 2007?
Ensure brevity in your answer.  0.98. What is the ratio of the Earning from trade(constant 2005 US) of Nicaragua in 2006 to that in 2007?
Offer a very short reply. 0.9. What is the ratio of the Earning from trade(constant 2005 US) of Bangladesh in 2006 to that in 2008?
Keep it short and to the point. 0.83. What is the ratio of the Earning from trade(constant 2005 US) in Nicaragua in 2006 to that in 2008?
Ensure brevity in your answer.  0.83. What is the ratio of the Earning from trade(constant 2005 US) of Bangladesh in 2006 to that in 2009?
Ensure brevity in your answer.  0.83. What is the ratio of the Earning from trade(constant 2005 US) of Montenegro in 2006 to that in 2009?
Offer a very short reply. 1.29. What is the ratio of the Earning from trade(constant 2005 US) in Nicaragua in 2006 to that in 2009?
Offer a terse response. 0.82. What is the ratio of the Earning from trade(constant 2005 US) in Bangladesh in 2007 to that in 2008?
Your answer should be very brief. 0.93. What is the ratio of the Earning from trade(constant 2005 US) in Montenegro in 2007 to that in 2008?
Ensure brevity in your answer.  1.02. What is the ratio of the Earning from trade(constant 2005 US) in Nicaragua in 2007 to that in 2008?
Keep it short and to the point. 0.92. What is the ratio of the Earning from trade(constant 2005 US) of Bangladesh in 2007 to that in 2009?
Make the answer very short. 0.93. What is the ratio of the Earning from trade(constant 2005 US) in Montenegro in 2007 to that in 2009?
Your answer should be very brief. 1.31. What is the ratio of the Earning from trade(constant 2005 US) in Nicaragua in 2007 to that in 2009?
Make the answer very short. 0.91. What is the ratio of the Earning from trade(constant 2005 US) in Montenegro in 2008 to that in 2009?
Provide a short and direct response. 1.29. What is the ratio of the Earning from trade(constant 2005 US) of Nicaragua in 2008 to that in 2009?
Give a very brief answer. 0.99. What is the difference between the highest and the second highest Earning from trade(constant 2005 US) of Bangladesh?
Your answer should be very brief. 4.32e+06. What is the difference between the highest and the second highest Earning from trade(constant 2005 US) in Montenegro?
Your answer should be very brief. 2.61e+07. What is the difference between the highest and the second highest Earning from trade(constant 2005 US) in Nicaragua?
Your response must be concise. 1.68e+07. What is the difference between the highest and the lowest Earning from trade(constant 2005 US) of Bangladesh?
Your answer should be compact. 1.14e+1. What is the difference between the highest and the lowest Earning from trade(constant 2005 US) in Montenegro?
Keep it short and to the point. 6.76e+08. What is the difference between the highest and the lowest Earning from trade(constant 2005 US) of Nicaragua?
Provide a short and direct response. 9.96e+08. 